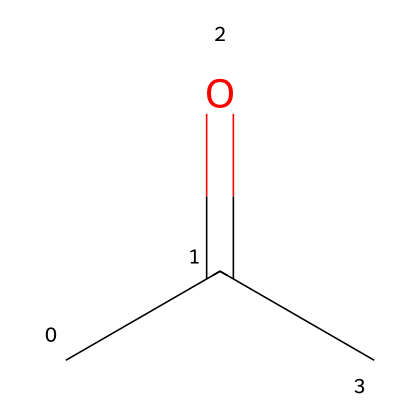What is the molecular formula of acetone? By analyzing the provided SMILES representation, we can identify that acetone consists of three carbon atoms (C), six hydrogen atoms (H), and one oxygen atom (O), leading us to derive the molecular formula C3H6O.
Answer: C3H6O How many carbon atoms are in acetone? Inspecting the SMILES structure CC(=O)C reveals three instances of the carbon letter 'C', representing three carbon atoms in the molecule.
Answer: 3 What type of functional group is present in acetone? The structure includes a carbonyl group (C=O) as indicated by the presence of the double bond to oxygen adjacent to carbon atoms, characteristic of ketones.
Answer: carbonyl Why is acetone considered a solvent? Acetone's structure has small and polar molecules that can disrupt the intermolecular forces in many substances, allowing it to dissolve a wide range of non-polar and polar compounds, thus functioning well as a solvent.
Answer: small and polar molecules What is the degree of saturation in acetone? The degree of saturation can be determined from the structure by counting the number of double bonds and rings; acetone has one double bond (C=O) and no rings making its degree of saturation equal to one.
Answer: 1 How many hydrogen atoms directly bond to the central carbon atom in acetone? By examining the structure, there are three hydrogen atoms directly bonded to the central carbon atom in the backbone of acetone.
Answer: 3 